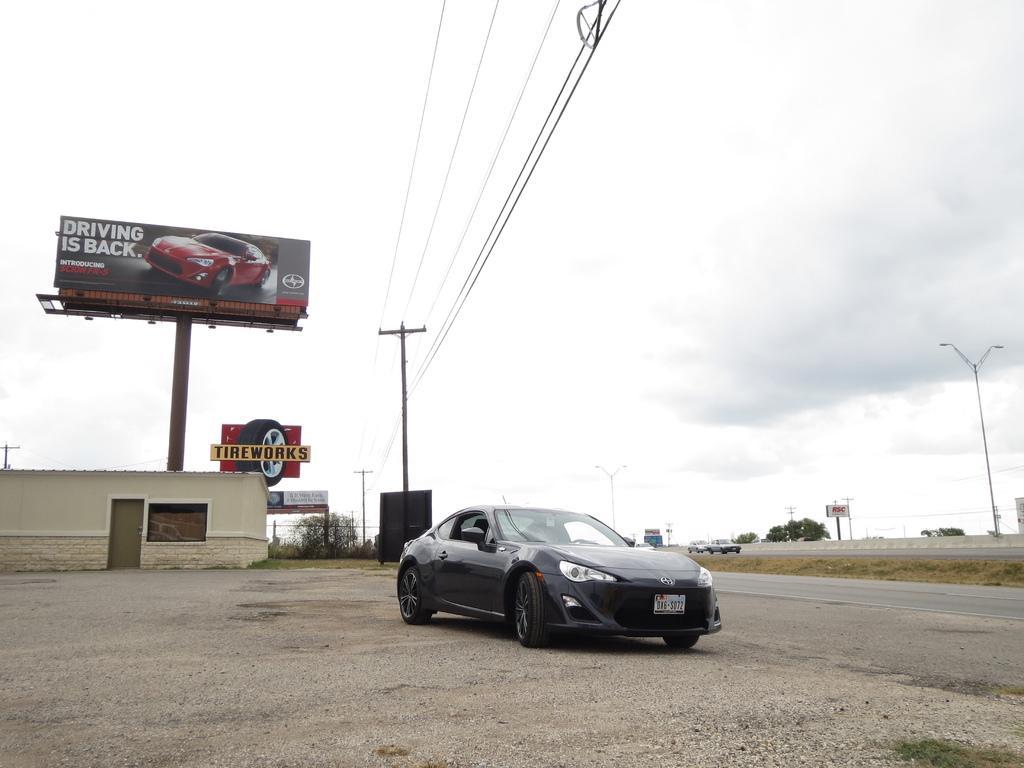Describe this image in one or two sentences. In this image in the center there is a car which is black in colour. In the background there are trees, poles, there are boards with some text written on it and there is a house and the sky is cloudy. 